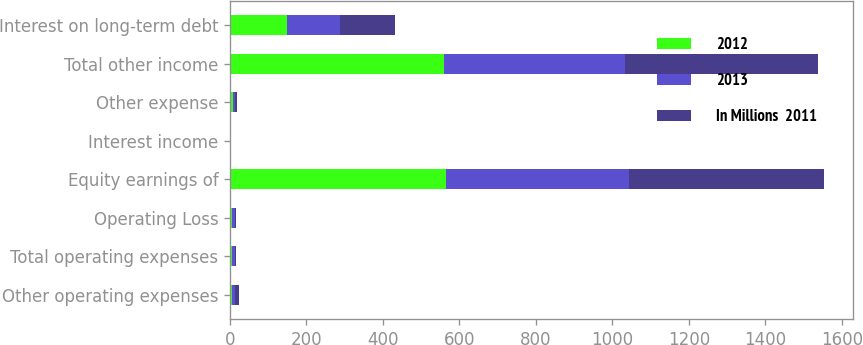Convert chart. <chart><loc_0><loc_0><loc_500><loc_500><stacked_bar_chart><ecel><fcel>Other operating expenses<fcel>Total operating expenses<fcel>Operating Loss<fcel>Equity earnings of<fcel>Interest income<fcel>Other expense<fcel>Total other income<fcel>Interest on long-term debt<nl><fcel>2012<fcel>6<fcel>6<fcel>6<fcel>566<fcel>1<fcel>8<fcel>559<fcel>148<nl><fcel>2013<fcel>8<fcel>8<fcel>8<fcel>477<fcel>1<fcel>5<fcel>473<fcel>140<nl><fcel>In Millions  2011<fcel>9<fcel>3<fcel>3<fcel>510<fcel>1<fcel>5<fcel>506<fcel>143<nl></chart> 